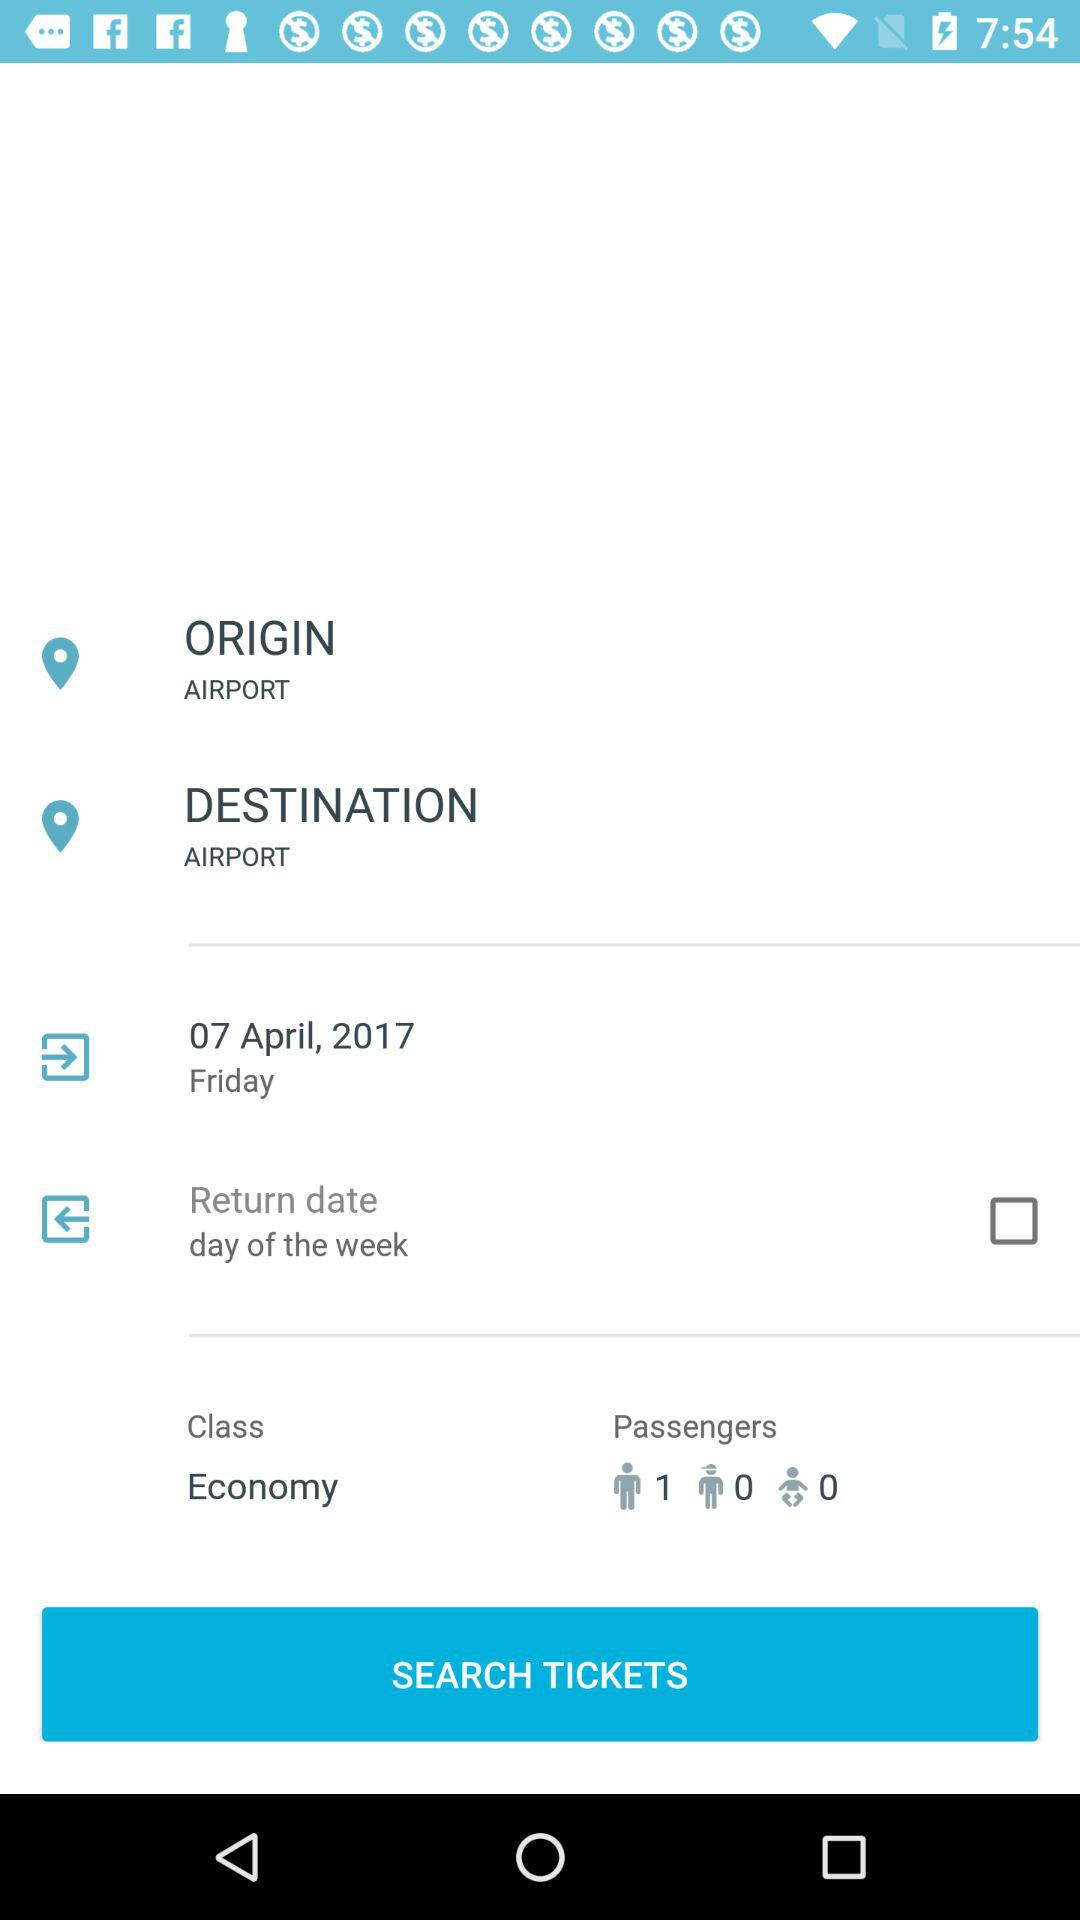How many passengers are flying?
Answer the question using a single word or phrase. 1 